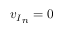<formula> <loc_0><loc_0><loc_500><loc_500>{ v _ { I } } _ { n } = 0</formula> 